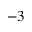Convert formula to latex. <formula><loc_0><loc_0><loc_500><loc_500>^ { - 3 }</formula> 